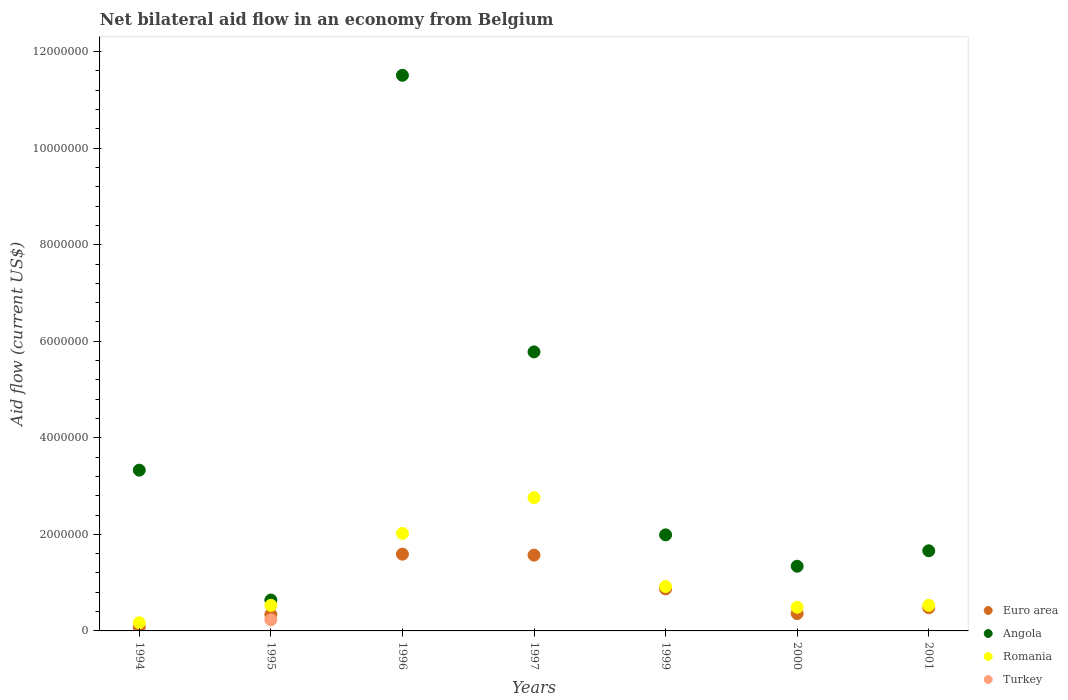How many different coloured dotlines are there?
Offer a very short reply. 4. What is the net bilateral aid flow in Angola in 1997?
Your answer should be compact. 5.78e+06. Across all years, what is the maximum net bilateral aid flow in Angola?
Provide a short and direct response. 1.15e+07. In which year was the net bilateral aid flow in Angola maximum?
Make the answer very short. 1996. What is the total net bilateral aid flow in Angola in the graph?
Ensure brevity in your answer.  2.62e+07. What is the difference between the net bilateral aid flow in Euro area in 1996 and that in 2001?
Provide a succinct answer. 1.11e+06. What is the difference between the net bilateral aid flow in Angola in 2000 and the net bilateral aid flow in Turkey in 2001?
Make the answer very short. 1.34e+06. What is the average net bilateral aid flow in Romania per year?
Your response must be concise. 1.06e+06. In the year 1995, what is the difference between the net bilateral aid flow in Euro area and net bilateral aid flow in Turkey?
Offer a terse response. 1.10e+05. In how many years, is the net bilateral aid flow in Angola greater than 1200000 US$?
Provide a succinct answer. 6. What is the ratio of the net bilateral aid flow in Angola in 1995 to that in 1996?
Provide a short and direct response. 0.06. What is the difference between the highest and the second highest net bilateral aid flow in Romania?
Ensure brevity in your answer.  7.40e+05. What is the difference between the highest and the lowest net bilateral aid flow in Euro area?
Offer a very short reply. 1.51e+06. In how many years, is the net bilateral aid flow in Euro area greater than the average net bilateral aid flow in Euro area taken over all years?
Your answer should be compact. 3. Is the sum of the net bilateral aid flow in Romania in 1994 and 1999 greater than the maximum net bilateral aid flow in Turkey across all years?
Your answer should be very brief. Yes. Is it the case that in every year, the sum of the net bilateral aid flow in Euro area and net bilateral aid flow in Romania  is greater than the net bilateral aid flow in Turkey?
Provide a succinct answer. Yes. Does the net bilateral aid flow in Romania monotonically increase over the years?
Give a very brief answer. No. Is the net bilateral aid flow in Turkey strictly greater than the net bilateral aid flow in Euro area over the years?
Give a very brief answer. No. Is the net bilateral aid flow in Angola strictly less than the net bilateral aid flow in Euro area over the years?
Make the answer very short. No. How many years are there in the graph?
Give a very brief answer. 7. Are the values on the major ticks of Y-axis written in scientific E-notation?
Your answer should be compact. No. What is the title of the graph?
Your response must be concise. Net bilateral aid flow in an economy from Belgium. Does "Uruguay" appear as one of the legend labels in the graph?
Keep it short and to the point. No. What is the label or title of the X-axis?
Provide a succinct answer. Years. What is the label or title of the Y-axis?
Keep it short and to the point. Aid flow (current US$). What is the Aid flow (current US$) in Euro area in 1994?
Offer a very short reply. 8.00e+04. What is the Aid flow (current US$) in Angola in 1994?
Offer a very short reply. 3.33e+06. What is the Aid flow (current US$) in Turkey in 1994?
Make the answer very short. 0. What is the Aid flow (current US$) of Angola in 1995?
Provide a succinct answer. 6.40e+05. What is the Aid flow (current US$) in Romania in 1995?
Offer a terse response. 5.30e+05. What is the Aid flow (current US$) in Turkey in 1995?
Make the answer very short. 2.30e+05. What is the Aid flow (current US$) of Euro area in 1996?
Ensure brevity in your answer.  1.59e+06. What is the Aid flow (current US$) of Angola in 1996?
Ensure brevity in your answer.  1.15e+07. What is the Aid flow (current US$) of Romania in 1996?
Your answer should be compact. 2.02e+06. What is the Aid flow (current US$) of Euro area in 1997?
Offer a terse response. 1.57e+06. What is the Aid flow (current US$) of Angola in 1997?
Your response must be concise. 5.78e+06. What is the Aid flow (current US$) in Romania in 1997?
Give a very brief answer. 2.76e+06. What is the Aid flow (current US$) of Turkey in 1997?
Offer a terse response. 0. What is the Aid flow (current US$) in Euro area in 1999?
Your answer should be compact. 8.70e+05. What is the Aid flow (current US$) in Angola in 1999?
Provide a short and direct response. 1.99e+06. What is the Aid flow (current US$) of Romania in 1999?
Offer a terse response. 9.20e+05. What is the Aid flow (current US$) of Angola in 2000?
Keep it short and to the point. 1.34e+06. What is the Aid flow (current US$) in Romania in 2000?
Your answer should be compact. 4.90e+05. What is the Aid flow (current US$) of Euro area in 2001?
Offer a very short reply. 4.80e+05. What is the Aid flow (current US$) of Angola in 2001?
Your response must be concise. 1.66e+06. What is the Aid flow (current US$) in Romania in 2001?
Offer a terse response. 5.30e+05. What is the Aid flow (current US$) in Turkey in 2001?
Your answer should be very brief. 0. Across all years, what is the maximum Aid flow (current US$) of Euro area?
Make the answer very short. 1.59e+06. Across all years, what is the maximum Aid flow (current US$) in Angola?
Offer a very short reply. 1.15e+07. Across all years, what is the maximum Aid flow (current US$) in Romania?
Keep it short and to the point. 2.76e+06. Across all years, what is the maximum Aid flow (current US$) of Turkey?
Your answer should be compact. 2.30e+05. Across all years, what is the minimum Aid flow (current US$) of Euro area?
Provide a short and direct response. 8.00e+04. Across all years, what is the minimum Aid flow (current US$) of Angola?
Offer a terse response. 6.40e+05. Across all years, what is the minimum Aid flow (current US$) of Romania?
Provide a short and direct response. 1.70e+05. What is the total Aid flow (current US$) of Euro area in the graph?
Your response must be concise. 5.29e+06. What is the total Aid flow (current US$) of Angola in the graph?
Ensure brevity in your answer.  2.62e+07. What is the total Aid flow (current US$) of Romania in the graph?
Your response must be concise. 7.42e+06. What is the difference between the Aid flow (current US$) of Angola in 1994 and that in 1995?
Ensure brevity in your answer.  2.69e+06. What is the difference between the Aid flow (current US$) of Romania in 1994 and that in 1995?
Ensure brevity in your answer.  -3.60e+05. What is the difference between the Aid flow (current US$) in Euro area in 1994 and that in 1996?
Give a very brief answer. -1.51e+06. What is the difference between the Aid flow (current US$) in Angola in 1994 and that in 1996?
Your answer should be compact. -8.18e+06. What is the difference between the Aid flow (current US$) in Romania in 1994 and that in 1996?
Give a very brief answer. -1.85e+06. What is the difference between the Aid flow (current US$) in Euro area in 1994 and that in 1997?
Your answer should be compact. -1.49e+06. What is the difference between the Aid flow (current US$) of Angola in 1994 and that in 1997?
Offer a terse response. -2.45e+06. What is the difference between the Aid flow (current US$) in Romania in 1994 and that in 1997?
Provide a succinct answer. -2.59e+06. What is the difference between the Aid flow (current US$) of Euro area in 1994 and that in 1999?
Offer a very short reply. -7.90e+05. What is the difference between the Aid flow (current US$) of Angola in 1994 and that in 1999?
Give a very brief answer. 1.34e+06. What is the difference between the Aid flow (current US$) in Romania in 1994 and that in 1999?
Offer a very short reply. -7.50e+05. What is the difference between the Aid flow (current US$) of Euro area in 1994 and that in 2000?
Make the answer very short. -2.80e+05. What is the difference between the Aid flow (current US$) of Angola in 1994 and that in 2000?
Your answer should be compact. 1.99e+06. What is the difference between the Aid flow (current US$) of Romania in 1994 and that in 2000?
Provide a short and direct response. -3.20e+05. What is the difference between the Aid flow (current US$) in Euro area in 1994 and that in 2001?
Provide a succinct answer. -4.00e+05. What is the difference between the Aid flow (current US$) of Angola in 1994 and that in 2001?
Provide a succinct answer. 1.67e+06. What is the difference between the Aid flow (current US$) in Romania in 1994 and that in 2001?
Your answer should be very brief. -3.60e+05. What is the difference between the Aid flow (current US$) in Euro area in 1995 and that in 1996?
Your response must be concise. -1.25e+06. What is the difference between the Aid flow (current US$) of Angola in 1995 and that in 1996?
Make the answer very short. -1.09e+07. What is the difference between the Aid flow (current US$) in Romania in 1995 and that in 1996?
Make the answer very short. -1.49e+06. What is the difference between the Aid flow (current US$) in Euro area in 1995 and that in 1997?
Give a very brief answer. -1.23e+06. What is the difference between the Aid flow (current US$) in Angola in 1995 and that in 1997?
Your answer should be very brief. -5.14e+06. What is the difference between the Aid flow (current US$) of Romania in 1995 and that in 1997?
Make the answer very short. -2.23e+06. What is the difference between the Aid flow (current US$) of Euro area in 1995 and that in 1999?
Your answer should be compact. -5.30e+05. What is the difference between the Aid flow (current US$) of Angola in 1995 and that in 1999?
Ensure brevity in your answer.  -1.35e+06. What is the difference between the Aid flow (current US$) in Romania in 1995 and that in 1999?
Your answer should be very brief. -3.90e+05. What is the difference between the Aid flow (current US$) in Angola in 1995 and that in 2000?
Your answer should be compact. -7.00e+05. What is the difference between the Aid flow (current US$) in Romania in 1995 and that in 2000?
Provide a short and direct response. 4.00e+04. What is the difference between the Aid flow (current US$) of Angola in 1995 and that in 2001?
Provide a succinct answer. -1.02e+06. What is the difference between the Aid flow (current US$) in Angola in 1996 and that in 1997?
Keep it short and to the point. 5.73e+06. What is the difference between the Aid flow (current US$) of Romania in 1996 and that in 1997?
Provide a short and direct response. -7.40e+05. What is the difference between the Aid flow (current US$) of Euro area in 1996 and that in 1999?
Keep it short and to the point. 7.20e+05. What is the difference between the Aid flow (current US$) in Angola in 1996 and that in 1999?
Your response must be concise. 9.52e+06. What is the difference between the Aid flow (current US$) in Romania in 1996 and that in 1999?
Make the answer very short. 1.10e+06. What is the difference between the Aid flow (current US$) of Euro area in 1996 and that in 2000?
Your answer should be very brief. 1.23e+06. What is the difference between the Aid flow (current US$) of Angola in 1996 and that in 2000?
Offer a terse response. 1.02e+07. What is the difference between the Aid flow (current US$) in Romania in 1996 and that in 2000?
Keep it short and to the point. 1.53e+06. What is the difference between the Aid flow (current US$) of Euro area in 1996 and that in 2001?
Offer a terse response. 1.11e+06. What is the difference between the Aid flow (current US$) of Angola in 1996 and that in 2001?
Your response must be concise. 9.85e+06. What is the difference between the Aid flow (current US$) in Romania in 1996 and that in 2001?
Your answer should be compact. 1.49e+06. What is the difference between the Aid flow (current US$) of Angola in 1997 and that in 1999?
Provide a succinct answer. 3.79e+06. What is the difference between the Aid flow (current US$) in Romania in 1997 and that in 1999?
Provide a short and direct response. 1.84e+06. What is the difference between the Aid flow (current US$) of Euro area in 1997 and that in 2000?
Your answer should be compact. 1.21e+06. What is the difference between the Aid flow (current US$) in Angola in 1997 and that in 2000?
Ensure brevity in your answer.  4.44e+06. What is the difference between the Aid flow (current US$) of Romania in 1997 and that in 2000?
Make the answer very short. 2.27e+06. What is the difference between the Aid flow (current US$) in Euro area in 1997 and that in 2001?
Your answer should be very brief. 1.09e+06. What is the difference between the Aid flow (current US$) of Angola in 1997 and that in 2001?
Give a very brief answer. 4.12e+06. What is the difference between the Aid flow (current US$) in Romania in 1997 and that in 2001?
Keep it short and to the point. 2.23e+06. What is the difference between the Aid flow (current US$) of Euro area in 1999 and that in 2000?
Offer a terse response. 5.10e+05. What is the difference between the Aid flow (current US$) of Angola in 1999 and that in 2000?
Ensure brevity in your answer.  6.50e+05. What is the difference between the Aid flow (current US$) of Euro area in 1999 and that in 2001?
Your answer should be compact. 3.90e+05. What is the difference between the Aid flow (current US$) in Angola in 1999 and that in 2001?
Offer a terse response. 3.30e+05. What is the difference between the Aid flow (current US$) in Romania in 1999 and that in 2001?
Make the answer very short. 3.90e+05. What is the difference between the Aid flow (current US$) in Euro area in 2000 and that in 2001?
Give a very brief answer. -1.20e+05. What is the difference between the Aid flow (current US$) in Angola in 2000 and that in 2001?
Keep it short and to the point. -3.20e+05. What is the difference between the Aid flow (current US$) in Euro area in 1994 and the Aid flow (current US$) in Angola in 1995?
Offer a terse response. -5.60e+05. What is the difference between the Aid flow (current US$) in Euro area in 1994 and the Aid flow (current US$) in Romania in 1995?
Provide a short and direct response. -4.50e+05. What is the difference between the Aid flow (current US$) of Euro area in 1994 and the Aid flow (current US$) of Turkey in 1995?
Give a very brief answer. -1.50e+05. What is the difference between the Aid flow (current US$) in Angola in 1994 and the Aid flow (current US$) in Romania in 1995?
Your answer should be very brief. 2.80e+06. What is the difference between the Aid flow (current US$) of Angola in 1994 and the Aid flow (current US$) of Turkey in 1995?
Provide a succinct answer. 3.10e+06. What is the difference between the Aid flow (current US$) of Euro area in 1994 and the Aid flow (current US$) of Angola in 1996?
Make the answer very short. -1.14e+07. What is the difference between the Aid flow (current US$) in Euro area in 1994 and the Aid flow (current US$) in Romania in 1996?
Ensure brevity in your answer.  -1.94e+06. What is the difference between the Aid flow (current US$) of Angola in 1994 and the Aid flow (current US$) of Romania in 1996?
Offer a terse response. 1.31e+06. What is the difference between the Aid flow (current US$) in Euro area in 1994 and the Aid flow (current US$) in Angola in 1997?
Keep it short and to the point. -5.70e+06. What is the difference between the Aid flow (current US$) in Euro area in 1994 and the Aid flow (current US$) in Romania in 1997?
Make the answer very short. -2.68e+06. What is the difference between the Aid flow (current US$) of Angola in 1994 and the Aid flow (current US$) of Romania in 1997?
Provide a short and direct response. 5.70e+05. What is the difference between the Aid flow (current US$) of Euro area in 1994 and the Aid flow (current US$) of Angola in 1999?
Offer a very short reply. -1.91e+06. What is the difference between the Aid flow (current US$) in Euro area in 1994 and the Aid flow (current US$) in Romania in 1999?
Make the answer very short. -8.40e+05. What is the difference between the Aid flow (current US$) in Angola in 1994 and the Aid flow (current US$) in Romania in 1999?
Provide a short and direct response. 2.41e+06. What is the difference between the Aid flow (current US$) in Euro area in 1994 and the Aid flow (current US$) in Angola in 2000?
Give a very brief answer. -1.26e+06. What is the difference between the Aid flow (current US$) in Euro area in 1994 and the Aid flow (current US$) in Romania in 2000?
Your answer should be compact. -4.10e+05. What is the difference between the Aid flow (current US$) in Angola in 1994 and the Aid flow (current US$) in Romania in 2000?
Your answer should be very brief. 2.84e+06. What is the difference between the Aid flow (current US$) in Euro area in 1994 and the Aid flow (current US$) in Angola in 2001?
Make the answer very short. -1.58e+06. What is the difference between the Aid flow (current US$) of Euro area in 1994 and the Aid flow (current US$) of Romania in 2001?
Your answer should be very brief. -4.50e+05. What is the difference between the Aid flow (current US$) of Angola in 1994 and the Aid flow (current US$) of Romania in 2001?
Offer a terse response. 2.80e+06. What is the difference between the Aid flow (current US$) of Euro area in 1995 and the Aid flow (current US$) of Angola in 1996?
Your response must be concise. -1.12e+07. What is the difference between the Aid flow (current US$) in Euro area in 1995 and the Aid flow (current US$) in Romania in 1996?
Make the answer very short. -1.68e+06. What is the difference between the Aid flow (current US$) in Angola in 1995 and the Aid flow (current US$) in Romania in 1996?
Provide a succinct answer. -1.38e+06. What is the difference between the Aid flow (current US$) of Euro area in 1995 and the Aid flow (current US$) of Angola in 1997?
Your response must be concise. -5.44e+06. What is the difference between the Aid flow (current US$) in Euro area in 1995 and the Aid flow (current US$) in Romania in 1997?
Your answer should be compact. -2.42e+06. What is the difference between the Aid flow (current US$) in Angola in 1995 and the Aid flow (current US$) in Romania in 1997?
Keep it short and to the point. -2.12e+06. What is the difference between the Aid flow (current US$) of Euro area in 1995 and the Aid flow (current US$) of Angola in 1999?
Offer a terse response. -1.65e+06. What is the difference between the Aid flow (current US$) in Euro area in 1995 and the Aid flow (current US$) in Romania in 1999?
Your response must be concise. -5.80e+05. What is the difference between the Aid flow (current US$) of Angola in 1995 and the Aid flow (current US$) of Romania in 1999?
Give a very brief answer. -2.80e+05. What is the difference between the Aid flow (current US$) of Euro area in 1995 and the Aid flow (current US$) of Angola in 2000?
Give a very brief answer. -1.00e+06. What is the difference between the Aid flow (current US$) in Angola in 1995 and the Aid flow (current US$) in Romania in 2000?
Your answer should be very brief. 1.50e+05. What is the difference between the Aid flow (current US$) in Euro area in 1995 and the Aid flow (current US$) in Angola in 2001?
Make the answer very short. -1.32e+06. What is the difference between the Aid flow (current US$) in Angola in 1995 and the Aid flow (current US$) in Romania in 2001?
Give a very brief answer. 1.10e+05. What is the difference between the Aid flow (current US$) of Euro area in 1996 and the Aid flow (current US$) of Angola in 1997?
Provide a succinct answer. -4.19e+06. What is the difference between the Aid flow (current US$) of Euro area in 1996 and the Aid flow (current US$) of Romania in 1997?
Your answer should be compact. -1.17e+06. What is the difference between the Aid flow (current US$) in Angola in 1996 and the Aid flow (current US$) in Romania in 1997?
Make the answer very short. 8.75e+06. What is the difference between the Aid flow (current US$) in Euro area in 1996 and the Aid flow (current US$) in Angola in 1999?
Make the answer very short. -4.00e+05. What is the difference between the Aid flow (current US$) in Euro area in 1996 and the Aid flow (current US$) in Romania in 1999?
Give a very brief answer. 6.70e+05. What is the difference between the Aid flow (current US$) of Angola in 1996 and the Aid flow (current US$) of Romania in 1999?
Give a very brief answer. 1.06e+07. What is the difference between the Aid flow (current US$) of Euro area in 1996 and the Aid flow (current US$) of Angola in 2000?
Offer a terse response. 2.50e+05. What is the difference between the Aid flow (current US$) in Euro area in 1996 and the Aid flow (current US$) in Romania in 2000?
Your answer should be compact. 1.10e+06. What is the difference between the Aid flow (current US$) in Angola in 1996 and the Aid flow (current US$) in Romania in 2000?
Your answer should be very brief. 1.10e+07. What is the difference between the Aid flow (current US$) of Euro area in 1996 and the Aid flow (current US$) of Romania in 2001?
Make the answer very short. 1.06e+06. What is the difference between the Aid flow (current US$) in Angola in 1996 and the Aid flow (current US$) in Romania in 2001?
Offer a very short reply. 1.10e+07. What is the difference between the Aid flow (current US$) of Euro area in 1997 and the Aid flow (current US$) of Angola in 1999?
Provide a succinct answer. -4.20e+05. What is the difference between the Aid flow (current US$) of Euro area in 1997 and the Aid flow (current US$) of Romania in 1999?
Your answer should be very brief. 6.50e+05. What is the difference between the Aid flow (current US$) of Angola in 1997 and the Aid flow (current US$) of Romania in 1999?
Provide a short and direct response. 4.86e+06. What is the difference between the Aid flow (current US$) in Euro area in 1997 and the Aid flow (current US$) in Romania in 2000?
Provide a short and direct response. 1.08e+06. What is the difference between the Aid flow (current US$) of Angola in 1997 and the Aid flow (current US$) of Romania in 2000?
Make the answer very short. 5.29e+06. What is the difference between the Aid flow (current US$) in Euro area in 1997 and the Aid flow (current US$) in Romania in 2001?
Offer a very short reply. 1.04e+06. What is the difference between the Aid flow (current US$) of Angola in 1997 and the Aid flow (current US$) of Romania in 2001?
Keep it short and to the point. 5.25e+06. What is the difference between the Aid flow (current US$) in Euro area in 1999 and the Aid flow (current US$) in Angola in 2000?
Your answer should be very brief. -4.70e+05. What is the difference between the Aid flow (current US$) in Angola in 1999 and the Aid flow (current US$) in Romania in 2000?
Your answer should be very brief. 1.50e+06. What is the difference between the Aid flow (current US$) in Euro area in 1999 and the Aid flow (current US$) in Angola in 2001?
Offer a very short reply. -7.90e+05. What is the difference between the Aid flow (current US$) in Euro area in 1999 and the Aid flow (current US$) in Romania in 2001?
Provide a short and direct response. 3.40e+05. What is the difference between the Aid flow (current US$) of Angola in 1999 and the Aid flow (current US$) of Romania in 2001?
Offer a terse response. 1.46e+06. What is the difference between the Aid flow (current US$) of Euro area in 2000 and the Aid flow (current US$) of Angola in 2001?
Ensure brevity in your answer.  -1.30e+06. What is the difference between the Aid flow (current US$) in Euro area in 2000 and the Aid flow (current US$) in Romania in 2001?
Provide a succinct answer. -1.70e+05. What is the difference between the Aid flow (current US$) of Angola in 2000 and the Aid flow (current US$) of Romania in 2001?
Make the answer very short. 8.10e+05. What is the average Aid flow (current US$) of Euro area per year?
Provide a short and direct response. 7.56e+05. What is the average Aid flow (current US$) in Angola per year?
Give a very brief answer. 3.75e+06. What is the average Aid flow (current US$) in Romania per year?
Offer a terse response. 1.06e+06. What is the average Aid flow (current US$) in Turkey per year?
Offer a very short reply. 3.29e+04. In the year 1994, what is the difference between the Aid flow (current US$) of Euro area and Aid flow (current US$) of Angola?
Your response must be concise. -3.25e+06. In the year 1994, what is the difference between the Aid flow (current US$) of Euro area and Aid flow (current US$) of Romania?
Offer a very short reply. -9.00e+04. In the year 1994, what is the difference between the Aid flow (current US$) of Angola and Aid flow (current US$) of Romania?
Ensure brevity in your answer.  3.16e+06. In the year 1995, what is the difference between the Aid flow (current US$) in Euro area and Aid flow (current US$) in Turkey?
Offer a terse response. 1.10e+05. In the year 1996, what is the difference between the Aid flow (current US$) in Euro area and Aid flow (current US$) in Angola?
Your answer should be very brief. -9.92e+06. In the year 1996, what is the difference between the Aid flow (current US$) in Euro area and Aid flow (current US$) in Romania?
Ensure brevity in your answer.  -4.30e+05. In the year 1996, what is the difference between the Aid flow (current US$) of Angola and Aid flow (current US$) of Romania?
Keep it short and to the point. 9.49e+06. In the year 1997, what is the difference between the Aid flow (current US$) of Euro area and Aid flow (current US$) of Angola?
Your answer should be very brief. -4.21e+06. In the year 1997, what is the difference between the Aid flow (current US$) of Euro area and Aid flow (current US$) of Romania?
Ensure brevity in your answer.  -1.19e+06. In the year 1997, what is the difference between the Aid flow (current US$) of Angola and Aid flow (current US$) of Romania?
Your answer should be compact. 3.02e+06. In the year 1999, what is the difference between the Aid flow (current US$) in Euro area and Aid flow (current US$) in Angola?
Provide a succinct answer. -1.12e+06. In the year 1999, what is the difference between the Aid flow (current US$) in Angola and Aid flow (current US$) in Romania?
Your answer should be very brief. 1.07e+06. In the year 2000, what is the difference between the Aid flow (current US$) in Euro area and Aid flow (current US$) in Angola?
Offer a terse response. -9.80e+05. In the year 2000, what is the difference between the Aid flow (current US$) in Euro area and Aid flow (current US$) in Romania?
Your answer should be compact. -1.30e+05. In the year 2000, what is the difference between the Aid flow (current US$) in Angola and Aid flow (current US$) in Romania?
Your answer should be compact. 8.50e+05. In the year 2001, what is the difference between the Aid flow (current US$) in Euro area and Aid flow (current US$) in Angola?
Keep it short and to the point. -1.18e+06. In the year 2001, what is the difference between the Aid flow (current US$) in Euro area and Aid flow (current US$) in Romania?
Your response must be concise. -5.00e+04. In the year 2001, what is the difference between the Aid flow (current US$) of Angola and Aid flow (current US$) of Romania?
Give a very brief answer. 1.13e+06. What is the ratio of the Aid flow (current US$) in Euro area in 1994 to that in 1995?
Your answer should be compact. 0.24. What is the ratio of the Aid flow (current US$) in Angola in 1994 to that in 1995?
Your response must be concise. 5.2. What is the ratio of the Aid flow (current US$) in Romania in 1994 to that in 1995?
Ensure brevity in your answer.  0.32. What is the ratio of the Aid flow (current US$) of Euro area in 1994 to that in 1996?
Provide a succinct answer. 0.05. What is the ratio of the Aid flow (current US$) in Angola in 1994 to that in 1996?
Give a very brief answer. 0.29. What is the ratio of the Aid flow (current US$) of Romania in 1994 to that in 1996?
Give a very brief answer. 0.08. What is the ratio of the Aid flow (current US$) of Euro area in 1994 to that in 1997?
Give a very brief answer. 0.05. What is the ratio of the Aid flow (current US$) in Angola in 1994 to that in 1997?
Make the answer very short. 0.58. What is the ratio of the Aid flow (current US$) of Romania in 1994 to that in 1997?
Your response must be concise. 0.06. What is the ratio of the Aid flow (current US$) in Euro area in 1994 to that in 1999?
Make the answer very short. 0.09. What is the ratio of the Aid flow (current US$) of Angola in 1994 to that in 1999?
Your answer should be compact. 1.67. What is the ratio of the Aid flow (current US$) of Romania in 1994 to that in 1999?
Your response must be concise. 0.18. What is the ratio of the Aid flow (current US$) of Euro area in 1994 to that in 2000?
Your answer should be compact. 0.22. What is the ratio of the Aid flow (current US$) of Angola in 1994 to that in 2000?
Provide a short and direct response. 2.49. What is the ratio of the Aid flow (current US$) in Romania in 1994 to that in 2000?
Your answer should be very brief. 0.35. What is the ratio of the Aid flow (current US$) of Angola in 1994 to that in 2001?
Keep it short and to the point. 2.01. What is the ratio of the Aid flow (current US$) of Romania in 1994 to that in 2001?
Provide a succinct answer. 0.32. What is the ratio of the Aid flow (current US$) of Euro area in 1995 to that in 1996?
Your answer should be very brief. 0.21. What is the ratio of the Aid flow (current US$) in Angola in 1995 to that in 1996?
Give a very brief answer. 0.06. What is the ratio of the Aid flow (current US$) of Romania in 1995 to that in 1996?
Offer a terse response. 0.26. What is the ratio of the Aid flow (current US$) of Euro area in 1995 to that in 1997?
Give a very brief answer. 0.22. What is the ratio of the Aid flow (current US$) in Angola in 1995 to that in 1997?
Provide a short and direct response. 0.11. What is the ratio of the Aid flow (current US$) of Romania in 1995 to that in 1997?
Offer a terse response. 0.19. What is the ratio of the Aid flow (current US$) in Euro area in 1995 to that in 1999?
Ensure brevity in your answer.  0.39. What is the ratio of the Aid flow (current US$) of Angola in 1995 to that in 1999?
Your answer should be compact. 0.32. What is the ratio of the Aid flow (current US$) of Romania in 1995 to that in 1999?
Make the answer very short. 0.58. What is the ratio of the Aid flow (current US$) in Euro area in 1995 to that in 2000?
Offer a very short reply. 0.94. What is the ratio of the Aid flow (current US$) in Angola in 1995 to that in 2000?
Your answer should be compact. 0.48. What is the ratio of the Aid flow (current US$) of Romania in 1995 to that in 2000?
Your answer should be compact. 1.08. What is the ratio of the Aid flow (current US$) of Euro area in 1995 to that in 2001?
Your response must be concise. 0.71. What is the ratio of the Aid flow (current US$) of Angola in 1995 to that in 2001?
Make the answer very short. 0.39. What is the ratio of the Aid flow (current US$) in Euro area in 1996 to that in 1997?
Your answer should be very brief. 1.01. What is the ratio of the Aid flow (current US$) in Angola in 1996 to that in 1997?
Ensure brevity in your answer.  1.99. What is the ratio of the Aid flow (current US$) in Romania in 1996 to that in 1997?
Make the answer very short. 0.73. What is the ratio of the Aid flow (current US$) of Euro area in 1996 to that in 1999?
Offer a very short reply. 1.83. What is the ratio of the Aid flow (current US$) in Angola in 1996 to that in 1999?
Provide a short and direct response. 5.78. What is the ratio of the Aid flow (current US$) in Romania in 1996 to that in 1999?
Your answer should be very brief. 2.2. What is the ratio of the Aid flow (current US$) in Euro area in 1996 to that in 2000?
Provide a short and direct response. 4.42. What is the ratio of the Aid flow (current US$) in Angola in 1996 to that in 2000?
Your response must be concise. 8.59. What is the ratio of the Aid flow (current US$) of Romania in 1996 to that in 2000?
Make the answer very short. 4.12. What is the ratio of the Aid flow (current US$) in Euro area in 1996 to that in 2001?
Provide a succinct answer. 3.31. What is the ratio of the Aid flow (current US$) of Angola in 1996 to that in 2001?
Give a very brief answer. 6.93. What is the ratio of the Aid flow (current US$) of Romania in 1996 to that in 2001?
Provide a short and direct response. 3.81. What is the ratio of the Aid flow (current US$) in Euro area in 1997 to that in 1999?
Provide a short and direct response. 1.8. What is the ratio of the Aid flow (current US$) of Angola in 1997 to that in 1999?
Make the answer very short. 2.9. What is the ratio of the Aid flow (current US$) in Romania in 1997 to that in 1999?
Provide a short and direct response. 3. What is the ratio of the Aid flow (current US$) in Euro area in 1997 to that in 2000?
Make the answer very short. 4.36. What is the ratio of the Aid flow (current US$) in Angola in 1997 to that in 2000?
Your answer should be very brief. 4.31. What is the ratio of the Aid flow (current US$) in Romania in 1997 to that in 2000?
Make the answer very short. 5.63. What is the ratio of the Aid flow (current US$) of Euro area in 1997 to that in 2001?
Your answer should be very brief. 3.27. What is the ratio of the Aid flow (current US$) in Angola in 1997 to that in 2001?
Provide a short and direct response. 3.48. What is the ratio of the Aid flow (current US$) of Romania in 1997 to that in 2001?
Your answer should be very brief. 5.21. What is the ratio of the Aid flow (current US$) of Euro area in 1999 to that in 2000?
Offer a terse response. 2.42. What is the ratio of the Aid flow (current US$) in Angola in 1999 to that in 2000?
Your answer should be compact. 1.49. What is the ratio of the Aid flow (current US$) of Romania in 1999 to that in 2000?
Offer a very short reply. 1.88. What is the ratio of the Aid flow (current US$) of Euro area in 1999 to that in 2001?
Offer a terse response. 1.81. What is the ratio of the Aid flow (current US$) of Angola in 1999 to that in 2001?
Give a very brief answer. 1.2. What is the ratio of the Aid flow (current US$) of Romania in 1999 to that in 2001?
Provide a short and direct response. 1.74. What is the ratio of the Aid flow (current US$) of Angola in 2000 to that in 2001?
Your answer should be compact. 0.81. What is the ratio of the Aid flow (current US$) of Romania in 2000 to that in 2001?
Give a very brief answer. 0.92. What is the difference between the highest and the second highest Aid flow (current US$) in Euro area?
Your answer should be compact. 2.00e+04. What is the difference between the highest and the second highest Aid flow (current US$) in Angola?
Keep it short and to the point. 5.73e+06. What is the difference between the highest and the second highest Aid flow (current US$) in Romania?
Provide a short and direct response. 7.40e+05. What is the difference between the highest and the lowest Aid flow (current US$) of Euro area?
Offer a very short reply. 1.51e+06. What is the difference between the highest and the lowest Aid flow (current US$) of Angola?
Make the answer very short. 1.09e+07. What is the difference between the highest and the lowest Aid flow (current US$) in Romania?
Your answer should be compact. 2.59e+06. 